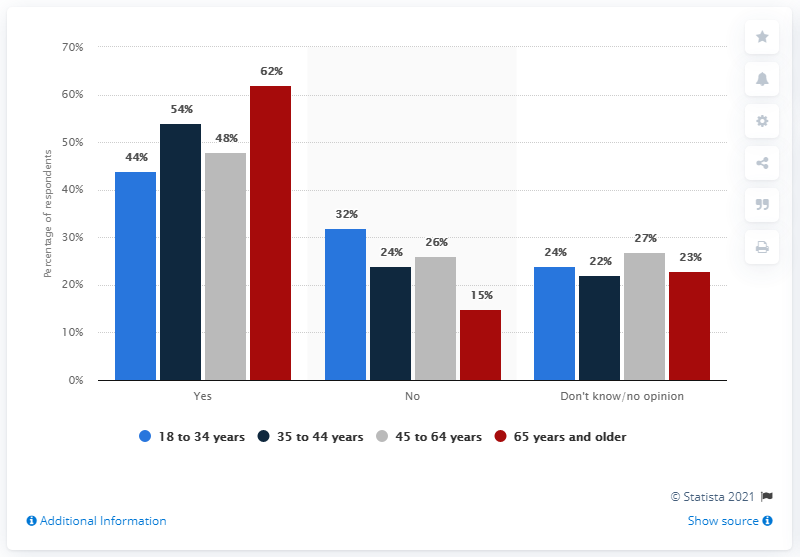List a handful of essential elements in this visual. According to a survey of adults aged 18 to 34, 44% reported that they would receive a coronavirus vaccine if it were available in the U.S. A survey found that 62% of people aged 65 and older in the United States stated that they would receive a coronavirus vaccine if it became available. According to the data provided, approximately 15% of elders in the county have chosen not to receive the COVID-19 vaccine. According to the study, 97% of people of all ages would not get the COVID-19 vaccine. 